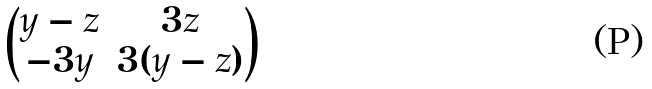<formula> <loc_0><loc_0><loc_500><loc_500>\begin{pmatrix} y - z & 3 z \\ - 3 y & 3 ( y - z ) \end{pmatrix}</formula> 